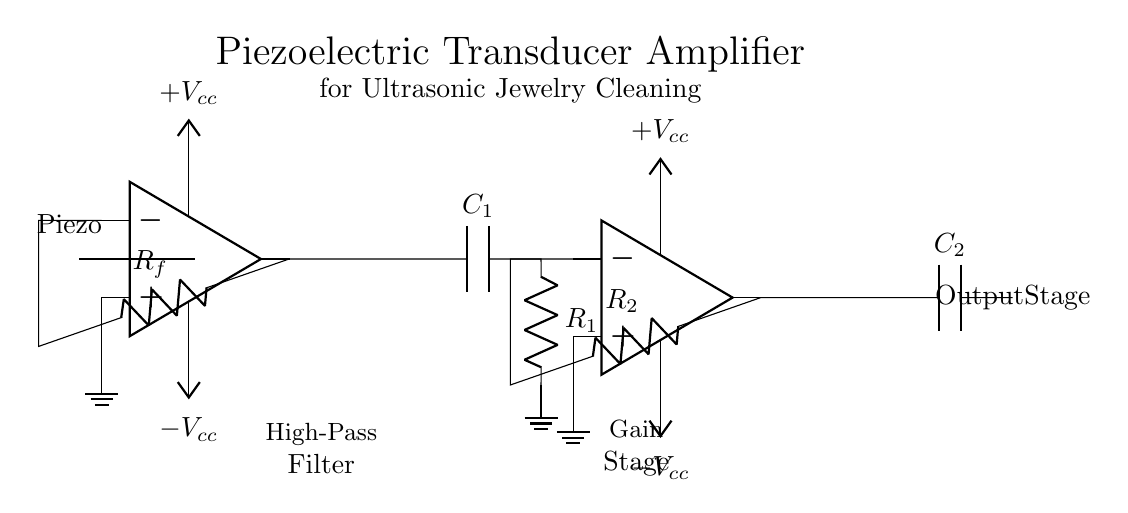What is the main component used in this circuit? The main component is a piezoelectric transducer, as indicated at the beginning of the circuit diagram.
Answer: Piezoelectric transducer What is the purpose of the capacitor labeled C1? Capacitor C1 is part of a high-pass filter, which allows high-frequency signals to pass while attenuating low-frequency signals.
Answer: High-pass filter How many operational amplifiers are present in the circuit? There are two operational amplifiers (OA1 and OA2) shown in the circuit diagram, each serving different amplification stages.
Answer: Two What is the role of resistor Rf in the circuit? Resistor Rf is a feedback resistor and is placed between the output of the first operational amplifier and its inverting input, which helps to set the gain of the amplifier.
Answer: Feedback resistor What voltage level is required to power the operational amplifiers? Each operational amplifier requires a dual power supply of positive and negative voltage, denoted as +Vcc and -Vcc, respectively, in the diagram.
Answer: Dual voltage What is the function of the two capacitors labeled C1 and C2? Capacitor C1 functions as a high-pass filter, while capacitor C2 is typically used for coupling or decoupling the output, ensuring that only AC signals are passed while blocking DC levels.
Answer: High-pass and coupling 